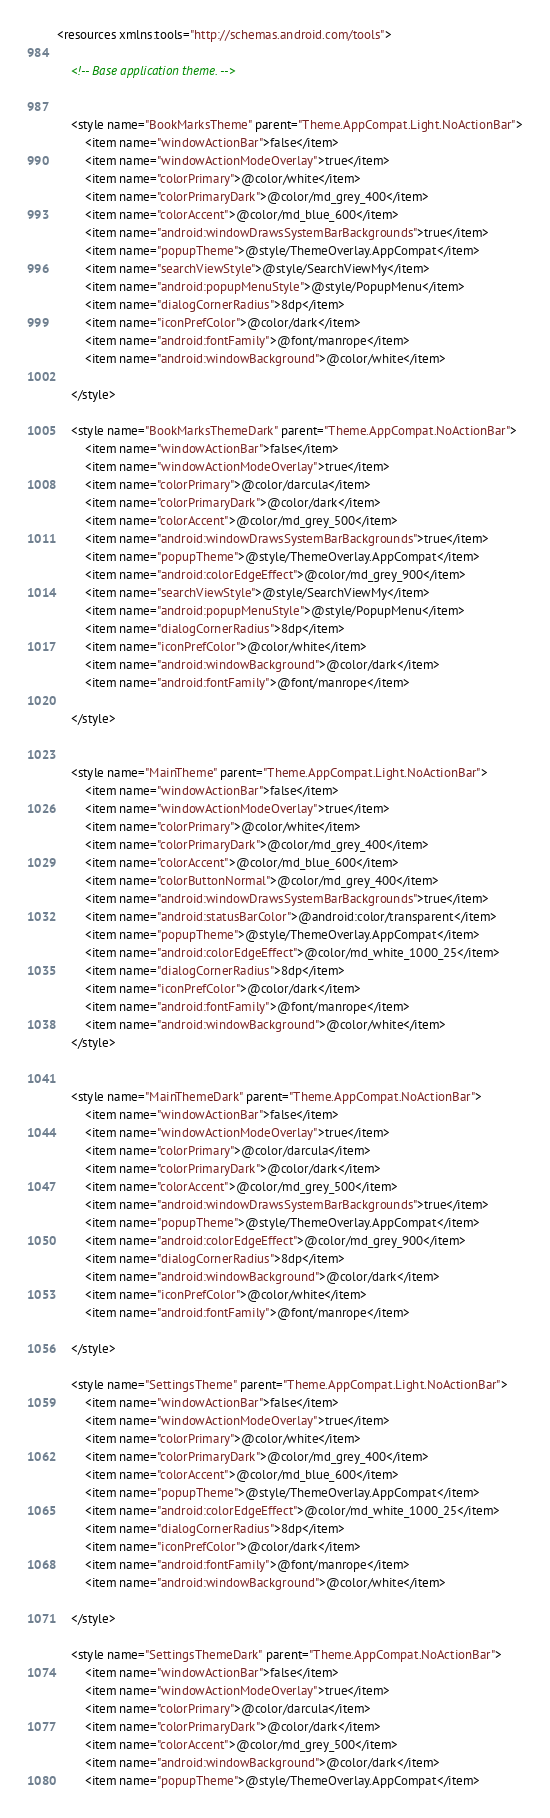Convert code to text. <code><loc_0><loc_0><loc_500><loc_500><_XML_><resources xmlns:tools="http://schemas.android.com/tools">

    <!-- Base application theme. -->


    <style name="BookMarksTheme" parent="Theme.AppCompat.Light.NoActionBar">
        <item name="windowActionBar">false</item>
        <item name="windowActionModeOverlay">true</item>
        <item name="colorPrimary">@color/white</item>
        <item name="colorPrimaryDark">@color/md_grey_400</item>
        <item name="colorAccent">@color/md_blue_600</item>
        <item name="android:windowDrawsSystemBarBackgrounds">true</item>
        <item name="popupTheme">@style/ThemeOverlay.AppCompat</item>
        <item name="searchViewStyle">@style/SearchViewMy</item>
        <item name="android:popupMenuStyle">@style/PopupMenu</item>
        <item name="dialogCornerRadius">8dp</item>
        <item name="iconPrefColor">@color/dark</item>
        <item name="android:fontFamily">@font/manrope</item>
        <item name="android:windowBackground">@color/white</item>

    </style>

    <style name="BookMarksThemeDark" parent="Theme.AppCompat.NoActionBar">
        <item name="windowActionBar">false</item>
        <item name="windowActionModeOverlay">true</item>
        <item name="colorPrimary">@color/darcula</item>
        <item name="colorPrimaryDark">@color/dark</item>
        <item name="colorAccent">@color/md_grey_500</item>
        <item name="android:windowDrawsSystemBarBackgrounds">true</item>
        <item name="popupTheme">@style/ThemeOverlay.AppCompat</item>
        <item name="android:colorEdgeEffect">@color/md_grey_900</item>
        <item name="searchViewStyle">@style/SearchViewMy</item>
        <item name="android:popupMenuStyle">@style/PopupMenu</item>
        <item name="dialogCornerRadius">8dp</item>
        <item name="iconPrefColor">@color/white</item>
        <item name="android:windowBackground">@color/dark</item>
        <item name="android:fontFamily">@font/manrope</item>

    </style>


    <style name="MainTheme" parent="Theme.AppCompat.Light.NoActionBar">
        <item name="windowActionBar">false</item>
        <item name="windowActionModeOverlay">true</item>
        <item name="colorPrimary">@color/white</item>
        <item name="colorPrimaryDark">@color/md_grey_400</item>
        <item name="colorAccent">@color/md_blue_600</item>
        <item name="colorButtonNormal">@color/md_grey_400</item>
        <item name="android:windowDrawsSystemBarBackgrounds">true</item>
        <item name="android:statusBarColor">@android:color/transparent</item>
        <item name="popupTheme">@style/ThemeOverlay.AppCompat</item>
        <item name="android:colorEdgeEffect">@color/md_white_1000_25</item>
        <item name="dialogCornerRadius">8dp</item>
        <item name="iconPrefColor">@color/dark</item>
        <item name="android:fontFamily">@font/manrope</item>
        <item name="android:windowBackground">@color/white</item>
    </style>


    <style name="MainThemeDark" parent="Theme.AppCompat.NoActionBar">
        <item name="windowActionBar">false</item>
        <item name="windowActionModeOverlay">true</item>
        <item name="colorPrimary">@color/darcula</item>
        <item name="colorPrimaryDark">@color/dark</item>
        <item name="colorAccent">@color/md_grey_500</item>
        <item name="android:windowDrawsSystemBarBackgrounds">true</item>
        <item name="popupTheme">@style/ThemeOverlay.AppCompat</item>
        <item name="android:colorEdgeEffect">@color/md_grey_900</item>
        <item name="dialogCornerRadius">8dp</item>
        <item name="android:windowBackground">@color/dark</item>
        <item name="iconPrefColor">@color/white</item>
        <item name="android:fontFamily">@font/manrope</item>

    </style>

    <style name="SettingsTheme" parent="Theme.AppCompat.Light.NoActionBar">
        <item name="windowActionBar">false</item>
        <item name="windowActionModeOverlay">true</item>
        <item name="colorPrimary">@color/white</item>
        <item name="colorPrimaryDark">@color/md_grey_400</item>
        <item name="colorAccent">@color/md_blue_600</item>
        <item name="popupTheme">@style/ThemeOverlay.AppCompat</item>
        <item name="android:colorEdgeEffect">@color/md_white_1000_25</item>
        <item name="dialogCornerRadius">8dp</item>
        <item name="iconPrefColor">@color/dark</item>
        <item name="android:fontFamily">@font/manrope</item>
        <item name="android:windowBackground">@color/white</item>

    </style>

    <style name="SettingsThemeDark" parent="Theme.AppCompat.NoActionBar">
        <item name="windowActionBar">false</item>
        <item name="windowActionModeOverlay">true</item>
        <item name="colorPrimary">@color/darcula</item>
        <item name="colorPrimaryDark">@color/dark</item>
        <item name="colorAccent">@color/md_grey_500</item>
        <item name="android:windowBackground">@color/dark</item>
        <item name="popupTheme">@style/ThemeOverlay.AppCompat</item></code> 